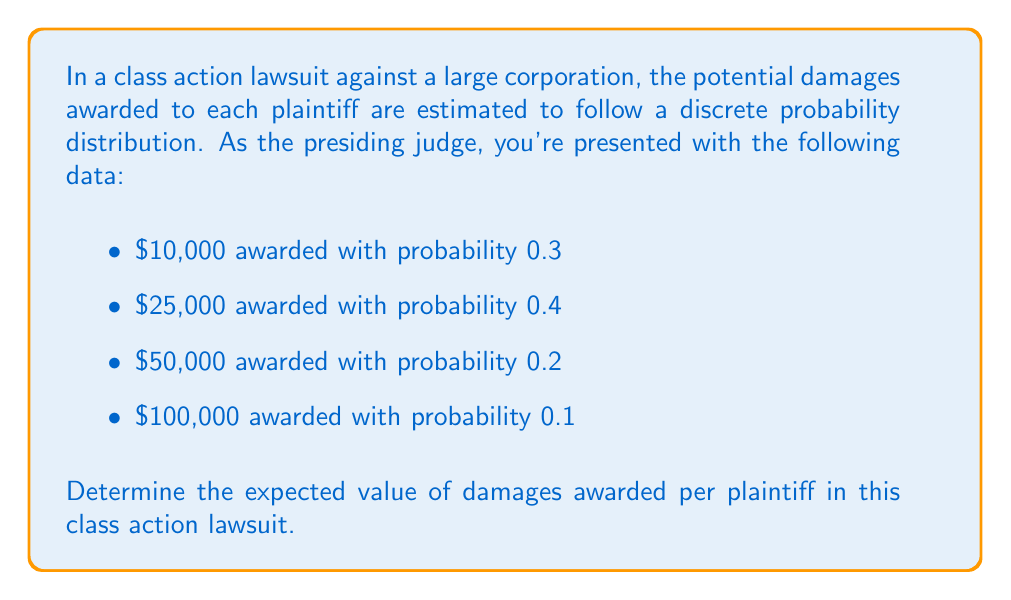Help me with this question. To determine the expected value of damages awarded per plaintiff, we need to calculate the sum of each possible outcome multiplied by its probability. This can be done using the formula for expected value:

$$E(X) = \sum_{i=1}^{n} x_i \cdot p(x_i)$$

Where $x_i$ represents each possible outcome, and $p(x_i)$ is the probability of that outcome.

Let's calculate each term:

1. $10,000 \cdot 0.3 = 3,000$
2. $25,000 \cdot 0.4 = 10,000$
3. $50,000 \cdot 0.2 = 10,000$
4. $100,000 \cdot 0.1 = 10,000$

Now, we sum these terms:

$$E(X) = 3,000 + 10,000 + 10,000 + 10,000 = 33,000$$

Therefore, the expected value of damages awarded per plaintiff is $33,000.

It's worth noting that this expected value provides a balanced perspective on the potential outcomes, which is crucial in legal proceedings where multiple viewpoints must be considered.
Answer: $33,000 